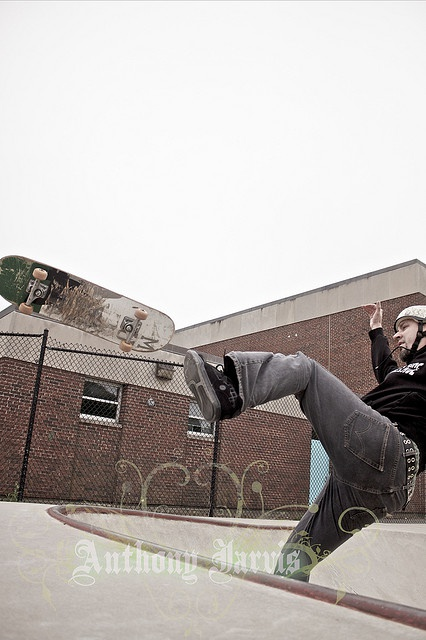Describe the objects in this image and their specific colors. I can see people in lightgray, black, gray, and darkgray tones and skateboard in lightgray, gray, darkgray, and black tones in this image. 